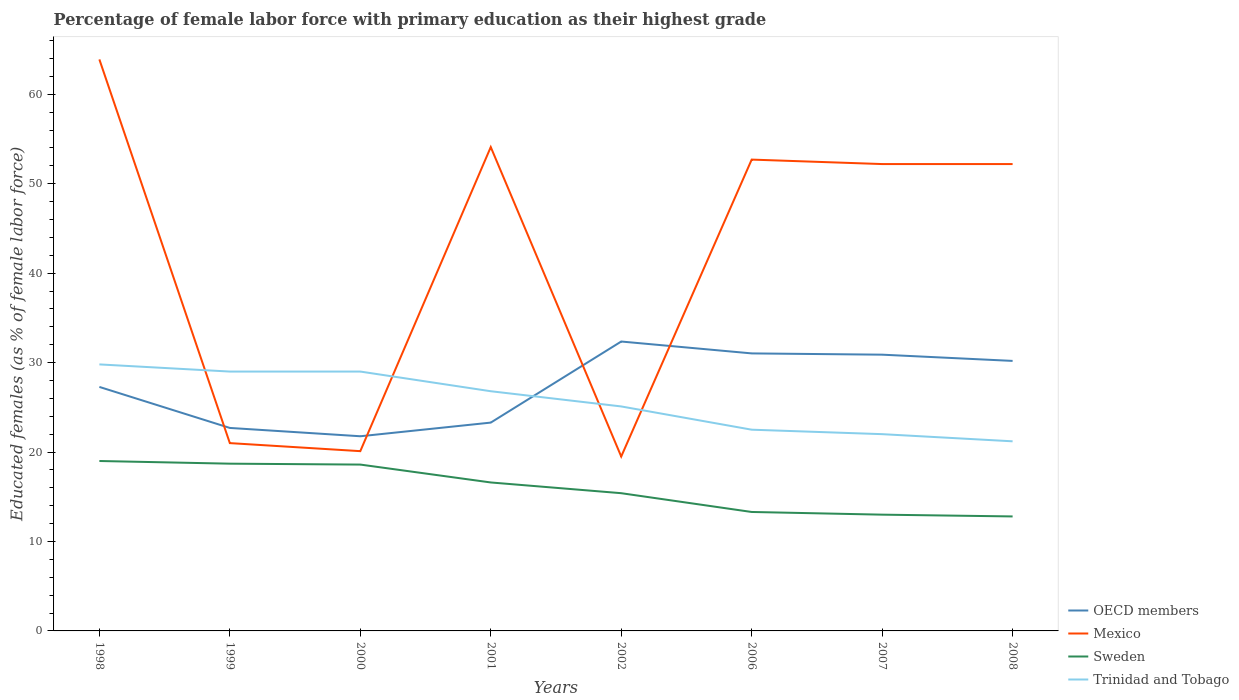How many different coloured lines are there?
Offer a terse response. 4. Does the line corresponding to Sweden intersect with the line corresponding to Trinidad and Tobago?
Keep it short and to the point. No. Across all years, what is the maximum percentage of female labor force with primary education in Sweden?
Your answer should be compact. 12.8. What is the total percentage of female labor force with primary education in Sweden in the graph?
Your answer should be compact. 2.1. What is the difference between the highest and the second highest percentage of female labor force with primary education in OECD members?
Keep it short and to the point. 10.59. What is the difference between the highest and the lowest percentage of female labor force with primary education in Trinidad and Tobago?
Provide a succinct answer. 4. Does the graph contain any zero values?
Your answer should be compact. No. Where does the legend appear in the graph?
Keep it short and to the point. Bottom right. How many legend labels are there?
Offer a terse response. 4. How are the legend labels stacked?
Your answer should be compact. Vertical. What is the title of the graph?
Make the answer very short. Percentage of female labor force with primary education as their highest grade. What is the label or title of the Y-axis?
Ensure brevity in your answer.  Educated females (as % of female labor force). What is the Educated females (as % of female labor force) of OECD members in 1998?
Give a very brief answer. 27.28. What is the Educated females (as % of female labor force) of Mexico in 1998?
Your answer should be very brief. 63.9. What is the Educated females (as % of female labor force) of Trinidad and Tobago in 1998?
Give a very brief answer. 29.8. What is the Educated females (as % of female labor force) of OECD members in 1999?
Your answer should be very brief. 22.7. What is the Educated females (as % of female labor force) in Mexico in 1999?
Give a very brief answer. 21. What is the Educated females (as % of female labor force) in Sweden in 1999?
Keep it short and to the point. 18.7. What is the Educated females (as % of female labor force) of Trinidad and Tobago in 1999?
Offer a very short reply. 29. What is the Educated females (as % of female labor force) of OECD members in 2000?
Ensure brevity in your answer.  21.77. What is the Educated females (as % of female labor force) in Mexico in 2000?
Give a very brief answer. 20.1. What is the Educated females (as % of female labor force) of Sweden in 2000?
Keep it short and to the point. 18.6. What is the Educated females (as % of female labor force) of OECD members in 2001?
Offer a very short reply. 23.29. What is the Educated females (as % of female labor force) of Mexico in 2001?
Your answer should be very brief. 54.1. What is the Educated females (as % of female labor force) of Sweden in 2001?
Offer a very short reply. 16.6. What is the Educated females (as % of female labor force) in Trinidad and Tobago in 2001?
Your response must be concise. 26.8. What is the Educated females (as % of female labor force) in OECD members in 2002?
Your answer should be very brief. 32.36. What is the Educated females (as % of female labor force) in Mexico in 2002?
Make the answer very short. 19.5. What is the Educated females (as % of female labor force) of Sweden in 2002?
Offer a terse response. 15.4. What is the Educated females (as % of female labor force) in Trinidad and Tobago in 2002?
Your response must be concise. 25.1. What is the Educated females (as % of female labor force) in OECD members in 2006?
Make the answer very short. 31.03. What is the Educated females (as % of female labor force) of Mexico in 2006?
Your answer should be compact. 52.7. What is the Educated females (as % of female labor force) of Sweden in 2006?
Provide a short and direct response. 13.3. What is the Educated females (as % of female labor force) in OECD members in 2007?
Provide a short and direct response. 30.89. What is the Educated females (as % of female labor force) of Mexico in 2007?
Ensure brevity in your answer.  52.2. What is the Educated females (as % of female labor force) in Sweden in 2007?
Your answer should be compact. 13. What is the Educated females (as % of female labor force) of Trinidad and Tobago in 2007?
Provide a short and direct response. 22. What is the Educated females (as % of female labor force) in OECD members in 2008?
Give a very brief answer. 30.19. What is the Educated females (as % of female labor force) of Mexico in 2008?
Your answer should be very brief. 52.2. What is the Educated females (as % of female labor force) of Sweden in 2008?
Give a very brief answer. 12.8. What is the Educated females (as % of female labor force) of Trinidad and Tobago in 2008?
Your answer should be compact. 21.2. Across all years, what is the maximum Educated females (as % of female labor force) of OECD members?
Offer a terse response. 32.36. Across all years, what is the maximum Educated females (as % of female labor force) in Mexico?
Ensure brevity in your answer.  63.9. Across all years, what is the maximum Educated females (as % of female labor force) of Sweden?
Your answer should be very brief. 19. Across all years, what is the maximum Educated females (as % of female labor force) of Trinidad and Tobago?
Offer a terse response. 29.8. Across all years, what is the minimum Educated females (as % of female labor force) of OECD members?
Your response must be concise. 21.77. Across all years, what is the minimum Educated females (as % of female labor force) in Mexico?
Provide a succinct answer. 19.5. Across all years, what is the minimum Educated females (as % of female labor force) in Sweden?
Your response must be concise. 12.8. Across all years, what is the minimum Educated females (as % of female labor force) in Trinidad and Tobago?
Make the answer very short. 21.2. What is the total Educated females (as % of female labor force) of OECD members in the graph?
Offer a terse response. 219.5. What is the total Educated females (as % of female labor force) in Mexico in the graph?
Your answer should be compact. 335.7. What is the total Educated females (as % of female labor force) of Sweden in the graph?
Ensure brevity in your answer.  127.4. What is the total Educated females (as % of female labor force) of Trinidad and Tobago in the graph?
Your response must be concise. 205.4. What is the difference between the Educated females (as % of female labor force) in OECD members in 1998 and that in 1999?
Provide a succinct answer. 4.59. What is the difference between the Educated females (as % of female labor force) of Mexico in 1998 and that in 1999?
Your answer should be compact. 42.9. What is the difference between the Educated females (as % of female labor force) of Sweden in 1998 and that in 1999?
Ensure brevity in your answer.  0.3. What is the difference between the Educated females (as % of female labor force) of OECD members in 1998 and that in 2000?
Give a very brief answer. 5.52. What is the difference between the Educated females (as % of female labor force) in Mexico in 1998 and that in 2000?
Provide a short and direct response. 43.8. What is the difference between the Educated females (as % of female labor force) of Sweden in 1998 and that in 2000?
Make the answer very short. 0.4. What is the difference between the Educated females (as % of female labor force) of Trinidad and Tobago in 1998 and that in 2000?
Make the answer very short. 0.8. What is the difference between the Educated females (as % of female labor force) of OECD members in 1998 and that in 2001?
Give a very brief answer. 3.99. What is the difference between the Educated females (as % of female labor force) of OECD members in 1998 and that in 2002?
Offer a terse response. -5.08. What is the difference between the Educated females (as % of female labor force) in Mexico in 1998 and that in 2002?
Offer a very short reply. 44.4. What is the difference between the Educated females (as % of female labor force) in OECD members in 1998 and that in 2006?
Your answer should be very brief. -3.75. What is the difference between the Educated females (as % of female labor force) of Mexico in 1998 and that in 2006?
Provide a short and direct response. 11.2. What is the difference between the Educated females (as % of female labor force) in Sweden in 1998 and that in 2006?
Make the answer very short. 5.7. What is the difference between the Educated females (as % of female labor force) of OECD members in 1998 and that in 2007?
Your answer should be very brief. -3.61. What is the difference between the Educated females (as % of female labor force) in Sweden in 1998 and that in 2007?
Offer a terse response. 6. What is the difference between the Educated females (as % of female labor force) of Trinidad and Tobago in 1998 and that in 2007?
Your answer should be compact. 7.8. What is the difference between the Educated females (as % of female labor force) in OECD members in 1998 and that in 2008?
Offer a very short reply. -2.91. What is the difference between the Educated females (as % of female labor force) in Sweden in 1998 and that in 2008?
Your answer should be very brief. 6.2. What is the difference between the Educated females (as % of female labor force) in Trinidad and Tobago in 1998 and that in 2008?
Offer a very short reply. 8.6. What is the difference between the Educated females (as % of female labor force) of OECD members in 1999 and that in 2000?
Keep it short and to the point. 0.93. What is the difference between the Educated females (as % of female labor force) of Sweden in 1999 and that in 2000?
Ensure brevity in your answer.  0.1. What is the difference between the Educated females (as % of female labor force) of OECD members in 1999 and that in 2001?
Give a very brief answer. -0.6. What is the difference between the Educated females (as % of female labor force) in Mexico in 1999 and that in 2001?
Offer a terse response. -33.1. What is the difference between the Educated females (as % of female labor force) in Trinidad and Tobago in 1999 and that in 2001?
Keep it short and to the point. 2.2. What is the difference between the Educated females (as % of female labor force) in OECD members in 1999 and that in 2002?
Provide a succinct answer. -9.66. What is the difference between the Educated females (as % of female labor force) in Sweden in 1999 and that in 2002?
Your answer should be compact. 3.3. What is the difference between the Educated females (as % of female labor force) of OECD members in 1999 and that in 2006?
Your answer should be very brief. -8.33. What is the difference between the Educated females (as % of female labor force) of Mexico in 1999 and that in 2006?
Ensure brevity in your answer.  -31.7. What is the difference between the Educated females (as % of female labor force) in Sweden in 1999 and that in 2006?
Give a very brief answer. 5.4. What is the difference between the Educated females (as % of female labor force) of OECD members in 1999 and that in 2007?
Keep it short and to the point. -8.19. What is the difference between the Educated females (as % of female labor force) of Mexico in 1999 and that in 2007?
Ensure brevity in your answer.  -31.2. What is the difference between the Educated females (as % of female labor force) of Sweden in 1999 and that in 2007?
Make the answer very short. 5.7. What is the difference between the Educated females (as % of female labor force) of Trinidad and Tobago in 1999 and that in 2007?
Ensure brevity in your answer.  7. What is the difference between the Educated females (as % of female labor force) of OECD members in 1999 and that in 2008?
Give a very brief answer. -7.5. What is the difference between the Educated females (as % of female labor force) of Mexico in 1999 and that in 2008?
Provide a succinct answer. -31.2. What is the difference between the Educated females (as % of female labor force) in Sweden in 1999 and that in 2008?
Offer a terse response. 5.9. What is the difference between the Educated females (as % of female labor force) in OECD members in 2000 and that in 2001?
Make the answer very short. -1.53. What is the difference between the Educated females (as % of female labor force) in Mexico in 2000 and that in 2001?
Give a very brief answer. -34. What is the difference between the Educated females (as % of female labor force) of Sweden in 2000 and that in 2001?
Make the answer very short. 2. What is the difference between the Educated females (as % of female labor force) of OECD members in 2000 and that in 2002?
Your answer should be compact. -10.59. What is the difference between the Educated females (as % of female labor force) of OECD members in 2000 and that in 2006?
Keep it short and to the point. -9.26. What is the difference between the Educated females (as % of female labor force) of Mexico in 2000 and that in 2006?
Provide a short and direct response. -32.6. What is the difference between the Educated females (as % of female labor force) in Trinidad and Tobago in 2000 and that in 2006?
Ensure brevity in your answer.  6.5. What is the difference between the Educated females (as % of female labor force) of OECD members in 2000 and that in 2007?
Offer a terse response. -9.12. What is the difference between the Educated females (as % of female labor force) in Mexico in 2000 and that in 2007?
Offer a terse response. -32.1. What is the difference between the Educated females (as % of female labor force) in Sweden in 2000 and that in 2007?
Your answer should be very brief. 5.6. What is the difference between the Educated females (as % of female labor force) of Trinidad and Tobago in 2000 and that in 2007?
Make the answer very short. 7. What is the difference between the Educated females (as % of female labor force) of OECD members in 2000 and that in 2008?
Ensure brevity in your answer.  -8.43. What is the difference between the Educated females (as % of female labor force) in Mexico in 2000 and that in 2008?
Keep it short and to the point. -32.1. What is the difference between the Educated females (as % of female labor force) in Trinidad and Tobago in 2000 and that in 2008?
Provide a succinct answer. 7.8. What is the difference between the Educated females (as % of female labor force) in OECD members in 2001 and that in 2002?
Keep it short and to the point. -9.07. What is the difference between the Educated females (as % of female labor force) of Mexico in 2001 and that in 2002?
Keep it short and to the point. 34.6. What is the difference between the Educated females (as % of female labor force) in Sweden in 2001 and that in 2002?
Your response must be concise. 1.2. What is the difference between the Educated females (as % of female labor force) in OECD members in 2001 and that in 2006?
Make the answer very short. -7.74. What is the difference between the Educated females (as % of female labor force) in Mexico in 2001 and that in 2006?
Offer a terse response. 1.4. What is the difference between the Educated females (as % of female labor force) of OECD members in 2001 and that in 2007?
Make the answer very short. -7.6. What is the difference between the Educated females (as % of female labor force) in Mexico in 2001 and that in 2007?
Offer a very short reply. 1.9. What is the difference between the Educated females (as % of female labor force) of Sweden in 2001 and that in 2007?
Your answer should be very brief. 3.6. What is the difference between the Educated females (as % of female labor force) of OECD members in 2001 and that in 2008?
Your answer should be compact. -6.9. What is the difference between the Educated females (as % of female labor force) of Mexico in 2001 and that in 2008?
Offer a terse response. 1.9. What is the difference between the Educated females (as % of female labor force) of Trinidad and Tobago in 2001 and that in 2008?
Provide a short and direct response. 5.6. What is the difference between the Educated females (as % of female labor force) in OECD members in 2002 and that in 2006?
Offer a very short reply. 1.33. What is the difference between the Educated females (as % of female labor force) of Mexico in 2002 and that in 2006?
Keep it short and to the point. -33.2. What is the difference between the Educated females (as % of female labor force) of Sweden in 2002 and that in 2006?
Ensure brevity in your answer.  2.1. What is the difference between the Educated females (as % of female labor force) of Trinidad and Tobago in 2002 and that in 2006?
Provide a short and direct response. 2.6. What is the difference between the Educated females (as % of female labor force) in OECD members in 2002 and that in 2007?
Keep it short and to the point. 1.47. What is the difference between the Educated females (as % of female labor force) in Mexico in 2002 and that in 2007?
Provide a succinct answer. -32.7. What is the difference between the Educated females (as % of female labor force) in OECD members in 2002 and that in 2008?
Offer a very short reply. 2.17. What is the difference between the Educated females (as % of female labor force) of Mexico in 2002 and that in 2008?
Your answer should be very brief. -32.7. What is the difference between the Educated females (as % of female labor force) in Sweden in 2002 and that in 2008?
Provide a succinct answer. 2.6. What is the difference between the Educated females (as % of female labor force) in OECD members in 2006 and that in 2007?
Ensure brevity in your answer.  0.14. What is the difference between the Educated females (as % of female labor force) in Sweden in 2006 and that in 2007?
Keep it short and to the point. 0.3. What is the difference between the Educated females (as % of female labor force) in OECD members in 2006 and that in 2008?
Your answer should be compact. 0.84. What is the difference between the Educated females (as % of female labor force) in OECD members in 2007 and that in 2008?
Provide a short and direct response. 0.7. What is the difference between the Educated females (as % of female labor force) of Mexico in 2007 and that in 2008?
Make the answer very short. 0. What is the difference between the Educated females (as % of female labor force) of Sweden in 2007 and that in 2008?
Your answer should be compact. 0.2. What is the difference between the Educated females (as % of female labor force) in Trinidad and Tobago in 2007 and that in 2008?
Give a very brief answer. 0.8. What is the difference between the Educated females (as % of female labor force) of OECD members in 1998 and the Educated females (as % of female labor force) of Mexico in 1999?
Offer a terse response. 6.28. What is the difference between the Educated females (as % of female labor force) in OECD members in 1998 and the Educated females (as % of female labor force) in Sweden in 1999?
Provide a short and direct response. 8.58. What is the difference between the Educated females (as % of female labor force) in OECD members in 1998 and the Educated females (as % of female labor force) in Trinidad and Tobago in 1999?
Ensure brevity in your answer.  -1.72. What is the difference between the Educated females (as % of female labor force) of Mexico in 1998 and the Educated females (as % of female labor force) of Sweden in 1999?
Give a very brief answer. 45.2. What is the difference between the Educated females (as % of female labor force) of Mexico in 1998 and the Educated females (as % of female labor force) of Trinidad and Tobago in 1999?
Your answer should be compact. 34.9. What is the difference between the Educated females (as % of female labor force) of OECD members in 1998 and the Educated females (as % of female labor force) of Mexico in 2000?
Offer a very short reply. 7.18. What is the difference between the Educated females (as % of female labor force) in OECD members in 1998 and the Educated females (as % of female labor force) in Sweden in 2000?
Offer a terse response. 8.68. What is the difference between the Educated females (as % of female labor force) of OECD members in 1998 and the Educated females (as % of female labor force) of Trinidad and Tobago in 2000?
Ensure brevity in your answer.  -1.72. What is the difference between the Educated females (as % of female labor force) of Mexico in 1998 and the Educated females (as % of female labor force) of Sweden in 2000?
Your answer should be compact. 45.3. What is the difference between the Educated females (as % of female labor force) in Mexico in 1998 and the Educated females (as % of female labor force) in Trinidad and Tobago in 2000?
Provide a succinct answer. 34.9. What is the difference between the Educated females (as % of female labor force) in OECD members in 1998 and the Educated females (as % of female labor force) in Mexico in 2001?
Give a very brief answer. -26.82. What is the difference between the Educated females (as % of female labor force) in OECD members in 1998 and the Educated females (as % of female labor force) in Sweden in 2001?
Make the answer very short. 10.68. What is the difference between the Educated females (as % of female labor force) of OECD members in 1998 and the Educated females (as % of female labor force) of Trinidad and Tobago in 2001?
Your answer should be compact. 0.48. What is the difference between the Educated females (as % of female labor force) of Mexico in 1998 and the Educated females (as % of female labor force) of Sweden in 2001?
Provide a succinct answer. 47.3. What is the difference between the Educated females (as % of female labor force) of Mexico in 1998 and the Educated females (as % of female labor force) of Trinidad and Tobago in 2001?
Your response must be concise. 37.1. What is the difference between the Educated females (as % of female labor force) of OECD members in 1998 and the Educated females (as % of female labor force) of Mexico in 2002?
Offer a very short reply. 7.78. What is the difference between the Educated females (as % of female labor force) of OECD members in 1998 and the Educated females (as % of female labor force) of Sweden in 2002?
Make the answer very short. 11.88. What is the difference between the Educated females (as % of female labor force) in OECD members in 1998 and the Educated females (as % of female labor force) in Trinidad and Tobago in 2002?
Your answer should be compact. 2.18. What is the difference between the Educated females (as % of female labor force) of Mexico in 1998 and the Educated females (as % of female labor force) of Sweden in 2002?
Offer a very short reply. 48.5. What is the difference between the Educated females (as % of female labor force) in Mexico in 1998 and the Educated females (as % of female labor force) in Trinidad and Tobago in 2002?
Your response must be concise. 38.8. What is the difference between the Educated females (as % of female labor force) of OECD members in 1998 and the Educated females (as % of female labor force) of Mexico in 2006?
Offer a very short reply. -25.42. What is the difference between the Educated females (as % of female labor force) of OECD members in 1998 and the Educated females (as % of female labor force) of Sweden in 2006?
Your answer should be very brief. 13.98. What is the difference between the Educated females (as % of female labor force) of OECD members in 1998 and the Educated females (as % of female labor force) of Trinidad and Tobago in 2006?
Your answer should be very brief. 4.78. What is the difference between the Educated females (as % of female labor force) of Mexico in 1998 and the Educated females (as % of female labor force) of Sweden in 2006?
Offer a terse response. 50.6. What is the difference between the Educated females (as % of female labor force) in Mexico in 1998 and the Educated females (as % of female labor force) in Trinidad and Tobago in 2006?
Provide a short and direct response. 41.4. What is the difference between the Educated females (as % of female labor force) in Sweden in 1998 and the Educated females (as % of female labor force) in Trinidad and Tobago in 2006?
Provide a succinct answer. -3.5. What is the difference between the Educated females (as % of female labor force) in OECD members in 1998 and the Educated females (as % of female labor force) in Mexico in 2007?
Provide a short and direct response. -24.92. What is the difference between the Educated females (as % of female labor force) of OECD members in 1998 and the Educated females (as % of female labor force) of Sweden in 2007?
Your answer should be compact. 14.28. What is the difference between the Educated females (as % of female labor force) of OECD members in 1998 and the Educated females (as % of female labor force) of Trinidad and Tobago in 2007?
Your answer should be very brief. 5.28. What is the difference between the Educated females (as % of female labor force) of Mexico in 1998 and the Educated females (as % of female labor force) of Sweden in 2007?
Your answer should be compact. 50.9. What is the difference between the Educated females (as % of female labor force) in Mexico in 1998 and the Educated females (as % of female labor force) in Trinidad and Tobago in 2007?
Ensure brevity in your answer.  41.9. What is the difference between the Educated females (as % of female labor force) of Sweden in 1998 and the Educated females (as % of female labor force) of Trinidad and Tobago in 2007?
Provide a succinct answer. -3. What is the difference between the Educated females (as % of female labor force) of OECD members in 1998 and the Educated females (as % of female labor force) of Mexico in 2008?
Your answer should be very brief. -24.92. What is the difference between the Educated females (as % of female labor force) of OECD members in 1998 and the Educated females (as % of female labor force) of Sweden in 2008?
Give a very brief answer. 14.48. What is the difference between the Educated females (as % of female labor force) of OECD members in 1998 and the Educated females (as % of female labor force) of Trinidad and Tobago in 2008?
Your response must be concise. 6.08. What is the difference between the Educated females (as % of female labor force) of Mexico in 1998 and the Educated females (as % of female labor force) of Sweden in 2008?
Offer a very short reply. 51.1. What is the difference between the Educated females (as % of female labor force) of Mexico in 1998 and the Educated females (as % of female labor force) of Trinidad and Tobago in 2008?
Make the answer very short. 42.7. What is the difference between the Educated females (as % of female labor force) of Sweden in 1998 and the Educated females (as % of female labor force) of Trinidad and Tobago in 2008?
Give a very brief answer. -2.2. What is the difference between the Educated females (as % of female labor force) of OECD members in 1999 and the Educated females (as % of female labor force) of Mexico in 2000?
Offer a very short reply. 2.6. What is the difference between the Educated females (as % of female labor force) of OECD members in 1999 and the Educated females (as % of female labor force) of Sweden in 2000?
Offer a terse response. 4.1. What is the difference between the Educated females (as % of female labor force) of OECD members in 1999 and the Educated females (as % of female labor force) of Trinidad and Tobago in 2000?
Make the answer very short. -6.3. What is the difference between the Educated females (as % of female labor force) in Mexico in 1999 and the Educated females (as % of female labor force) in Trinidad and Tobago in 2000?
Your response must be concise. -8. What is the difference between the Educated females (as % of female labor force) of Sweden in 1999 and the Educated females (as % of female labor force) of Trinidad and Tobago in 2000?
Provide a succinct answer. -10.3. What is the difference between the Educated females (as % of female labor force) of OECD members in 1999 and the Educated females (as % of female labor force) of Mexico in 2001?
Your answer should be very brief. -31.4. What is the difference between the Educated females (as % of female labor force) of OECD members in 1999 and the Educated females (as % of female labor force) of Sweden in 2001?
Offer a very short reply. 6.1. What is the difference between the Educated females (as % of female labor force) of OECD members in 1999 and the Educated females (as % of female labor force) of Trinidad and Tobago in 2001?
Your answer should be compact. -4.1. What is the difference between the Educated females (as % of female labor force) in Mexico in 1999 and the Educated females (as % of female labor force) in Sweden in 2001?
Your response must be concise. 4.4. What is the difference between the Educated females (as % of female labor force) in OECD members in 1999 and the Educated females (as % of female labor force) in Mexico in 2002?
Provide a short and direct response. 3.2. What is the difference between the Educated females (as % of female labor force) in OECD members in 1999 and the Educated females (as % of female labor force) in Sweden in 2002?
Make the answer very short. 7.3. What is the difference between the Educated females (as % of female labor force) of OECD members in 1999 and the Educated females (as % of female labor force) of Trinidad and Tobago in 2002?
Give a very brief answer. -2.4. What is the difference between the Educated females (as % of female labor force) of Sweden in 1999 and the Educated females (as % of female labor force) of Trinidad and Tobago in 2002?
Keep it short and to the point. -6.4. What is the difference between the Educated females (as % of female labor force) of OECD members in 1999 and the Educated females (as % of female labor force) of Mexico in 2006?
Offer a terse response. -30. What is the difference between the Educated females (as % of female labor force) of OECD members in 1999 and the Educated females (as % of female labor force) of Sweden in 2006?
Provide a succinct answer. 9.4. What is the difference between the Educated females (as % of female labor force) of OECD members in 1999 and the Educated females (as % of female labor force) of Trinidad and Tobago in 2006?
Make the answer very short. 0.2. What is the difference between the Educated females (as % of female labor force) of Mexico in 1999 and the Educated females (as % of female labor force) of Sweden in 2006?
Keep it short and to the point. 7.7. What is the difference between the Educated females (as % of female labor force) in Mexico in 1999 and the Educated females (as % of female labor force) in Trinidad and Tobago in 2006?
Your response must be concise. -1.5. What is the difference between the Educated females (as % of female labor force) in OECD members in 1999 and the Educated females (as % of female labor force) in Mexico in 2007?
Provide a succinct answer. -29.5. What is the difference between the Educated females (as % of female labor force) of OECD members in 1999 and the Educated females (as % of female labor force) of Sweden in 2007?
Ensure brevity in your answer.  9.7. What is the difference between the Educated females (as % of female labor force) in OECD members in 1999 and the Educated females (as % of female labor force) in Trinidad and Tobago in 2007?
Provide a succinct answer. 0.7. What is the difference between the Educated females (as % of female labor force) in Mexico in 1999 and the Educated females (as % of female labor force) in Sweden in 2007?
Offer a very short reply. 8. What is the difference between the Educated females (as % of female labor force) of Mexico in 1999 and the Educated females (as % of female labor force) of Trinidad and Tobago in 2007?
Offer a very short reply. -1. What is the difference between the Educated females (as % of female labor force) in Sweden in 1999 and the Educated females (as % of female labor force) in Trinidad and Tobago in 2007?
Provide a short and direct response. -3.3. What is the difference between the Educated females (as % of female labor force) of OECD members in 1999 and the Educated females (as % of female labor force) of Mexico in 2008?
Your answer should be compact. -29.5. What is the difference between the Educated females (as % of female labor force) of OECD members in 1999 and the Educated females (as % of female labor force) of Sweden in 2008?
Make the answer very short. 9.9. What is the difference between the Educated females (as % of female labor force) in OECD members in 1999 and the Educated females (as % of female labor force) in Trinidad and Tobago in 2008?
Your answer should be compact. 1.5. What is the difference between the Educated females (as % of female labor force) of OECD members in 2000 and the Educated females (as % of female labor force) of Mexico in 2001?
Your answer should be compact. -32.33. What is the difference between the Educated females (as % of female labor force) in OECD members in 2000 and the Educated females (as % of female labor force) in Sweden in 2001?
Give a very brief answer. 5.17. What is the difference between the Educated females (as % of female labor force) of OECD members in 2000 and the Educated females (as % of female labor force) of Trinidad and Tobago in 2001?
Ensure brevity in your answer.  -5.03. What is the difference between the Educated females (as % of female labor force) in OECD members in 2000 and the Educated females (as % of female labor force) in Mexico in 2002?
Make the answer very short. 2.27. What is the difference between the Educated females (as % of female labor force) of OECD members in 2000 and the Educated females (as % of female labor force) of Sweden in 2002?
Provide a succinct answer. 6.37. What is the difference between the Educated females (as % of female labor force) of OECD members in 2000 and the Educated females (as % of female labor force) of Trinidad and Tobago in 2002?
Make the answer very short. -3.33. What is the difference between the Educated females (as % of female labor force) of Mexico in 2000 and the Educated females (as % of female labor force) of Sweden in 2002?
Give a very brief answer. 4.7. What is the difference between the Educated females (as % of female labor force) in Sweden in 2000 and the Educated females (as % of female labor force) in Trinidad and Tobago in 2002?
Offer a terse response. -6.5. What is the difference between the Educated females (as % of female labor force) in OECD members in 2000 and the Educated females (as % of female labor force) in Mexico in 2006?
Provide a succinct answer. -30.93. What is the difference between the Educated females (as % of female labor force) of OECD members in 2000 and the Educated females (as % of female labor force) of Sweden in 2006?
Provide a short and direct response. 8.47. What is the difference between the Educated females (as % of female labor force) in OECD members in 2000 and the Educated females (as % of female labor force) in Trinidad and Tobago in 2006?
Your answer should be compact. -0.73. What is the difference between the Educated females (as % of female labor force) in Mexico in 2000 and the Educated females (as % of female labor force) in Trinidad and Tobago in 2006?
Your answer should be very brief. -2.4. What is the difference between the Educated females (as % of female labor force) of OECD members in 2000 and the Educated females (as % of female labor force) of Mexico in 2007?
Offer a very short reply. -30.43. What is the difference between the Educated females (as % of female labor force) of OECD members in 2000 and the Educated females (as % of female labor force) of Sweden in 2007?
Provide a succinct answer. 8.77. What is the difference between the Educated females (as % of female labor force) of OECD members in 2000 and the Educated females (as % of female labor force) of Trinidad and Tobago in 2007?
Provide a succinct answer. -0.23. What is the difference between the Educated females (as % of female labor force) of OECD members in 2000 and the Educated females (as % of female labor force) of Mexico in 2008?
Keep it short and to the point. -30.43. What is the difference between the Educated females (as % of female labor force) in OECD members in 2000 and the Educated females (as % of female labor force) in Sweden in 2008?
Provide a short and direct response. 8.97. What is the difference between the Educated females (as % of female labor force) in OECD members in 2000 and the Educated females (as % of female labor force) in Trinidad and Tobago in 2008?
Ensure brevity in your answer.  0.57. What is the difference between the Educated females (as % of female labor force) in Mexico in 2000 and the Educated females (as % of female labor force) in Sweden in 2008?
Your response must be concise. 7.3. What is the difference between the Educated females (as % of female labor force) of Sweden in 2000 and the Educated females (as % of female labor force) of Trinidad and Tobago in 2008?
Keep it short and to the point. -2.6. What is the difference between the Educated females (as % of female labor force) in OECD members in 2001 and the Educated females (as % of female labor force) in Mexico in 2002?
Keep it short and to the point. 3.79. What is the difference between the Educated females (as % of female labor force) in OECD members in 2001 and the Educated females (as % of female labor force) in Sweden in 2002?
Ensure brevity in your answer.  7.89. What is the difference between the Educated females (as % of female labor force) in OECD members in 2001 and the Educated females (as % of female labor force) in Trinidad and Tobago in 2002?
Keep it short and to the point. -1.81. What is the difference between the Educated females (as % of female labor force) in Mexico in 2001 and the Educated females (as % of female labor force) in Sweden in 2002?
Keep it short and to the point. 38.7. What is the difference between the Educated females (as % of female labor force) in OECD members in 2001 and the Educated females (as % of female labor force) in Mexico in 2006?
Ensure brevity in your answer.  -29.41. What is the difference between the Educated females (as % of female labor force) in OECD members in 2001 and the Educated females (as % of female labor force) in Sweden in 2006?
Keep it short and to the point. 9.99. What is the difference between the Educated females (as % of female labor force) in OECD members in 2001 and the Educated females (as % of female labor force) in Trinidad and Tobago in 2006?
Give a very brief answer. 0.79. What is the difference between the Educated females (as % of female labor force) in Mexico in 2001 and the Educated females (as % of female labor force) in Sweden in 2006?
Offer a terse response. 40.8. What is the difference between the Educated females (as % of female labor force) in Mexico in 2001 and the Educated females (as % of female labor force) in Trinidad and Tobago in 2006?
Keep it short and to the point. 31.6. What is the difference between the Educated females (as % of female labor force) in Sweden in 2001 and the Educated females (as % of female labor force) in Trinidad and Tobago in 2006?
Provide a succinct answer. -5.9. What is the difference between the Educated females (as % of female labor force) in OECD members in 2001 and the Educated females (as % of female labor force) in Mexico in 2007?
Your answer should be very brief. -28.91. What is the difference between the Educated females (as % of female labor force) in OECD members in 2001 and the Educated females (as % of female labor force) in Sweden in 2007?
Ensure brevity in your answer.  10.29. What is the difference between the Educated females (as % of female labor force) of OECD members in 2001 and the Educated females (as % of female labor force) of Trinidad and Tobago in 2007?
Your answer should be very brief. 1.29. What is the difference between the Educated females (as % of female labor force) of Mexico in 2001 and the Educated females (as % of female labor force) of Sweden in 2007?
Ensure brevity in your answer.  41.1. What is the difference between the Educated females (as % of female labor force) in Mexico in 2001 and the Educated females (as % of female labor force) in Trinidad and Tobago in 2007?
Offer a terse response. 32.1. What is the difference between the Educated females (as % of female labor force) in OECD members in 2001 and the Educated females (as % of female labor force) in Mexico in 2008?
Make the answer very short. -28.91. What is the difference between the Educated females (as % of female labor force) of OECD members in 2001 and the Educated females (as % of female labor force) of Sweden in 2008?
Ensure brevity in your answer.  10.49. What is the difference between the Educated females (as % of female labor force) in OECD members in 2001 and the Educated females (as % of female labor force) in Trinidad and Tobago in 2008?
Keep it short and to the point. 2.09. What is the difference between the Educated females (as % of female labor force) in Mexico in 2001 and the Educated females (as % of female labor force) in Sweden in 2008?
Your answer should be compact. 41.3. What is the difference between the Educated females (as % of female labor force) in Mexico in 2001 and the Educated females (as % of female labor force) in Trinidad and Tobago in 2008?
Provide a short and direct response. 32.9. What is the difference between the Educated females (as % of female labor force) of Sweden in 2001 and the Educated females (as % of female labor force) of Trinidad and Tobago in 2008?
Your response must be concise. -4.6. What is the difference between the Educated females (as % of female labor force) in OECD members in 2002 and the Educated females (as % of female labor force) in Mexico in 2006?
Make the answer very short. -20.34. What is the difference between the Educated females (as % of female labor force) of OECD members in 2002 and the Educated females (as % of female labor force) of Sweden in 2006?
Your response must be concise. 19.06. What is the difference between the Educated females (as % of female labor force) in OECD members in 2002 and the Educated females (as % of female labor force) in Trinidad and Tobago in 2006?
Provide a succinct answer. 9.86. What is the difference between the Educated females (as % of female labor force) of Mexico in 2002 and the Educated females (as % of female labor force) of Trinidad and Tobago in 2006?
Provide a short and direct response. -3. What is the difference between the Educated females (as % of female labor force) of OECD members in 2002 and the Educated females (as % of female labor force) of Mexico in 2007?
Give a very brief answer. -19.84. What is the difference between the Educated females (as % of female labor force) in OECD members in 2002 and the Educated females (as % of female labor force) in Sweden in 2007?
Your response must be concise. 19.36. What is the difference between the Educated females (as % of female labor force) of OECD members in 2002 and the Educated females (as % of female labor force) of Trinidad and Tobago in 2007?
Provide a short and direct response. 10.36. What is the difference between the Educated females (as % of female labor force) in Mexico in 2002 and the Educated females (as % of female labor force) in Trinidad and Tobago in 2007?
Ensure brevity in your answer.  -2.5. What is the difference between the Educated females (as % of female labor force) of Sweden in 2002 and the Educated females (as % of female labor force) of Trinidad and Tobago in 2007?
Your answer should be very brief. -6.6. What is the difference between the Educated females (as % of female labor force) of OECD members in 2002 and the Educated females (as % of female labor force) of Mexico in 2008?
Your answer should be compact. -19.84. What is the difference between the Educated females (as % of female labor force) of OECD members in 2002 and the Educated females (as % of female labor force) of Sweden in 2008?
Ensure brevity in your answer.  19.56. What is the difference between the Educated females (as % of female labor force) of OECD members in 2002 and the Educated females (as % of female labor force) of Trinidad and Tobago in 2008?
Offer a very short reply. 11.16. What is the difference between the Educated females (as % of female labor force) of Mexico in 2002 and the Educated females (as % of female labor force) of Sweden in 2008?
Give a very brief answer. 6.7. What is the difference between the Educated females (as % of female labor force) in OECD members in 2006 and the Educated females (as % of female labor force) in Mexico in 2007?
Ensure brevity in your answer.  -21.17. What is the difference between the Educated females (as % of female labor force) in OECD members in 2006 and the Educated females (as % of female labor force) in Sweden in 2007?
Ensure brevity in your answer.  18.03. What is the difference between the Educated females (as % of female labor force) in OECD members in 2006 and the Educated females (as % of female labor force) in Trinidad and Tobago in 2007?
Provide a succinct answer. 9.03. What is the difference between the Educated females (as % of female labor force) in Mexico in 2006 and the Educated females (as % of female labor force) in Sweden in 2007?
Your answer should be compact. 39.7. What is the difference between the Educated females (as % of female labor force) of Mexico in 2006 and the Educated females (as % of female labor force) of Trinidad and Tobago in 2007?
Offer a terse response. 30.7. What is the difference between the Educated females (as % of female labor force) of OECD members in 2006 and the Educated females (as % of female labor force) of Mexico in 2008?
Keep it short and to the point. -21.17. What is the difference between the Educated females (as % of female labor force) in OECD members in 2006 and the Educated females (as % of female labor force) in Sweden in 2008?
Your answer should be compact. 18.23. What is the difference between the Educated females (as % of female labor force) in OECD members in 2006 and the Educated females (as % of female labor force) in Trinidad and Tobago in 2008?
Make the answer very short. 9.83. What is the difference between the Educated females (as % of female labor force) of Mexico in 2006 and the Educated females (as % of female labor force) of Sweden in 2008?
Ensure brevity in your answer.  39.9. What is the difference between the Educated females (as % of female labor force) in Mexico in 2006 and the Educated females (as % of female labor force) in Trinidad and Tobago in 2008?
Make the answer very short. 31.5. What is the difference between the Educated females (as % of female labor force) of OECD members in 2007 and the Educated females (as % of female labor force) of Mexico in 2008?
Provide a short and direct response. -21.31. What is the difference between the Educated females (as % of female labor force) in OECD members in 2007 and the Educated females (as % of female labor force) in Sweden in 2008?
Keep it short and to the point. 18.09. What is the difference between the Educated females (as % of female labor force) of OECD members in 2007 and the Educated females (as % of female labor force) of Trinidad and Tobago in 2008?
Your answer should be compact. 9.69. What is the difference between the Educated females (as % of female labor force) in Mexico in 2007 and the Educated females (as % of female labor force) in Sweden in 2008?
Your answer should be very brief. 39.4. What is the difference between the Educated females (as % of female labor force) in Sweden in 2007 and the Educated females (as % of female labor force) in Trinidad and Tobago in 2008?
Offer a very short reply. -8.2. What is the average Educated females (as % of female labor force) of OECD members per year?
Give a very brief answer. 27.44. What is the average Educated females (as % of female labor force) of Mexico per year?
Your response must be concise. 41.96. What is the average Educated females (as % of female labor force) of Sweden per year?
Your answer should be very brief. 15.93. What is the average Educated females (as % of female labor force) in Trinidad and Tobago per year?
Your answer should be very brief. 25.68. In the year 1998, what is the difference between the Educated females (as % of female labor force) of OECD members and Educated females (as % of female labor force) of Mexico?
Ensure brevity in your answer.  -36.62. In the year 1998, what is the difference between the Educated females (as % of female labor force) in OECD members and Educated females (as % of female labor force) in Sweden?
Give a very brief answer. 8.28. In the year 1998, what is the difference between the Educated females (as % of female labor force) in OECD members and Educated females (as % of female labor force) in Trinidad and Tobago?
Give a very brief answer. -2.52. In the year 1998, what is the difference between the Educated females (as % of female labor force) of Mexico and Educated females (as % of female labor force) of Sweden?
Keep it short and to the point. 44.9. In the year 1998, what is the difference between the Educated females (as % of female labor force) of Mexico and Educated females (as % of female labor force) of Trinidad and Tobago?
Make the answer very short. 34.1. In the year 1998, what is the difference between the Educated females (as % of female labor force) in Sweden and Educated females (as % of female labor force) in Trinidad and Tobago?
Make the answer very short. -10.8. In the year 1999, what is the difference between the Educated females (as % of female labor force) of OECD members and Educated females (as % of female labor force) of Mexico?
Provide a short and direct response. 1.7. In the year 1999, what is the difference between the Educated females (as % of female labor force) in OECD members and Educated females (as % of female labor force) in Sweden?
Provide a succinct answer. 4. In the year 1999, what is the difference between the Educated females (as % of female labor force) in OECD members and Educated females (as % of female labor force) in Trinidad and Tobago?
Keep it short and to the point. -6.3. In the year 2000, what is the difference between the Educated females (as % of female labor force) of OECD members and Educated females (as % of female labor force) of Mexico?
Your response must be concise. 1.67. In the year 2000, what is the difference between the Educated females (as % of female labor force) of OECD members and Educated females (as % of female labor force) of Sweden?
Provide a succinct answer. 3.17. In the year 2000, what is the difference between the Educated females (as % of female labor force) in OECD members and Educated females (as % of female labor force) in Trinidad and Tobago?
Give a very brief answer. -7.23. In the year 2000, what is the difference between the Educated females (as % of female labor force) of Mexico and Educated females (as % of female labor force) of Sweden?
Offer a very short reply. 1.5. In the year 2000, what is the difference between the Educated females (as % of female labor force) in Mexico and Educated females (as % of female labor force) in Trinidad and Tobago?
Your answer should be very brief. -8.9. In the year 2001, what is the difference between the Educated females (as % of female labor force) in OECD members and Educated females (as % of female labor force) in Mexico?
Keep it short and to the point. -30.81. In the year 2001, what is the difference between the Educated females (as % of female labor force) in OECD members and Educated females (as % of female labor force) in Sweden?
Give a very brief answer. 6.69. In the year 2001, what is the difference between the Educated females (as % of female labor force) of OECD members and Educated females (as % of female labor force) of Trinidad and Tobago?
Keep it short and to the point. -3.51. In the year 2001, what is the difference between the Educated females (as % of female labor force) of Mexico and Educated females (as % of female labor force) of Sweden?
Your answer should be very brief. 37.5. In the year 2001, what is the difference between the Educated females (as % of female labor force) of Mexico and Educated females (as % of female labor force) of Trinidad and Tobago?
Your answer should be very brief. 27.3. In the year 2002, what is the difference between the Educated females (as % of female labor force) in OECD members and Educated females (as % of female labor force) in Mexico?
Your response must be concise. 12.86. In the year 2002, what is the difference between the Educated females (as % of female labor force) of OECD members and Educated females (as % of female labor force) of Sweden?
Offer a terse response. 16.96. In the year 2002, what is the difference between the Educated females (as % of female labor force) in OECD members and Educated females (as % of female labor force) in Trinidad and Tobago?
Offer a terse response. 7.26. In the year 2002, what is the difference between the Educated females (as % of female labor force) of Sweden and Educated females (as % of female labor force) of Trinidad and Tobago?
Offer a terse response. -9.7. In the year 2006, what is the difference between the Educated females (as % of female labor force) of OECD members and Educated females (as % of female labor force) of Mexico?
Give a very brief answer. -21.67. In the year 2006, what is the difference between the Educated females (as % of female labor force) in OECD members and Educated females (as % of female labor force) in Sweden?
Keep it short and to the point. 17.73. In the year 2006, what is the difference between the Educated females (as % of female labor force) of OECD members and Educated females (as % of female labor force) of Trinidad and Tobago?
Your answer should be very brief. 8.53. In the year 2006, what is the difference between the Educated females (as % of female labor force) in Mexico and Educated females (as % of female labor force) in Sweden?
Provide a short and direct response. 39.4. In the year 2006, what is the difference between the Educated females (as % of female labor force) in Mexico and Educated females (as % of female labor force) in Trinidad and Tobago?
Your answer should be very brief. 30.2. In the year 2006, what is the difference between the Educated females (as % of female labor force) in Sweden and Educated females (as % of female labor force) in Trinidad and Tobago?
Offer a terse response. -9.2. In the year 2007, what is the difference between the Educated females (as % of female labor force) of OECD members and Educated females (as % of female labor force) of Mexico?
Give a very brief answer. -21.31. In the year 2007, what is the difference between the Educated females (as % of female labor force) in OECD members and Educated females (as % of female labor force) in Sweden?
Your response must be concise. 17.89. In the year 2007, what is the difference between the Educated females (as % of female labor force) in OECD members and Educated females (as % of female labor force) in Trinidad and Tobago?
Your answer should be very brief. 8.89. In the year 2007, what is the difference between the Educated females (as % of female labor force) in Mexico and Educated females (as % of female labor force) in Sweden?
Ensure brevity in your answer.  39.2. In the year 2007, what is the difference between the Educated females (as % of female labor force) in Mexico and Educated females (as % of female labor force) in Trinidad and Tobago?
Give a very brief answer. 30.2. In the year 2008, what is the difference between the Educated females (as % of female labor force) of OECD members and Educated females (as % of female labor force) of Mexico?
Provide a succinct answer. -22.01. In the year 2008, what is the difference between the Educated females (as % of female labor force) of OECD members and Educated females (as % of female labor force) of Sweden?
Make the answer very short. 17.39. In the year 2008, what is the difference between the Educated females (as % of female labor force) of OECD members and Educated females (as % of female labor force) of Trinidad and Tobago?
Give a very brief answer. 8.99. In the year 2008, what is the difference between the Educated females (as % of female labor force) in Mexico and Educated females (as % of female labor force) in Sweden?
Your answer should be compact. 39.4. What is the ratio of the Educated females (as % of female labor force) of OECD members in 1998 to that in 1999?
Your answer should be compact. 1.2. What is the ratio of the Educated females (as % of female labor force) of Mexico in 1998 to that in 1999?
Provide a succinct answer. 3.04. What is the ratio of the Educated females (as % of female labor force) in Sweden in 1998 to that in 1999?
Provide a short and direct response. 1.02. What is the ratio of the Educated females (as % of female labor force) in Trinidad and Tobago in 1998 to that in 1999?
Give a very brief answer. 1.03. What is the ratio of the Educated females (as % of female labor force) of OECD members in 1998 to that in 2000?
Give a very brief answer. 1.25. What is the ratio of the Educated females (as % of female labor force) of Mexico in 1998 to that in 2000?
Give a very brief answer. 3.18. What is the ratio of the Educated females (as % of female labor force) of Sweden in 1998 to that in 2000?
Your answer should be very brief. 1.02. What is the ratio of the Educated females (as % of female labor force) of Trinidad and Tobago in 1998 to that in 2000?
Your answer should be very brief. 1.03. What is the ratio of the Educated females (as % of female labor force) in OECD members in 1998 to that in 2001?
Offer a very short reply. 1.17. What is the ratio of the Educated females (as % of female labor force) in Mexico in 1998 to that in 2001?
Make the answer very short. 1.18. What is the ratio of the Educated females (as % of female labor force) in Sweden in 1998 to that in 2001?
Your answer should be compact. 1.14. What is the ratio of the Educated females (as % of female labor force) in Trinidad and Tobago in 1998 to that in 2001?
Provide a short and direct response. 1.11. What is the ratio of the Educated females (as % of female labor force) in OECD members in 1998 to that in 2002?
Your answer should be very brief. 0.84. What is the ratio of the Educated females (as % of female labor force) of Mexico in 1998 to that in 2002?
Give a very brief answer. 3.28. What is the ratio of the Educated females (as % of female labor force) of Sweden in 1998 to that in 2002?
Provide a short and direct response. 1.23. What is the ratio of the Educated females (as % of female labor force) in Trinidad and Tobago in 1998 to that in 2002?
Keep it short and to the point. 1.19. What is the ratio of the Educated females (as % of female labor force) of OECD members in 1998 to that in 2006?
Your response must be concise. 0.88. What is the ratio of the Educated females (as % of female labor force) of Mexico in 1998 to that in 2006?
Offer a terse response. 1.21. What is the ratio of the Educated females (as % of female labor force) of Sweden in 1998 to that in 2006?
Make the answer very short. 1.43. What is the ratio of the Educated females (as % of female labor force) of Trinidad and Tobago in 1998 to that in 2006?
Your answer should be very brief. 1.32. What is the ratio of the Educated females (as % of female labor force) in OECD members in 1998 to that in 2007?
Your response must be concise. 0.88. What is the ratio of the Educated females (as % of female labor force) of Mexico in 1998 to that in 2007?
Offer a terse response. 1.22. What is the ratio of the Educated females (as % of female labor force) of Sweden in 1998 to that in 2007?
Ensure brevity in your answer.  1.46. What is the ratio of the Educated females (as % of female labor force) in Trinidad and Tobago in 1998 to that in 2007?
Your answer should be compact. 1.35. What is the ratio of the Educated females (as % of female labor force) in OECD members in 1998 to that in 2008?
Your answer should be very brief. 0.9. What is the ratio of the Educated females (as % of female labor force) of Mexico in 1998 to that in 2008?
Your answer should be very brief. 1.22. What is the ratio of the Educated females (as % of female labor force) in Sweden in 1998 to that in 2008?
Offer a very short reply. 1.48. What is the ratio of the Educated females (as % of female labor force) of Trinidad and Tobago in 1998 to that in 2008?
Provide a succinct answer. 1.41. What is the ratio of the Educated females (as % of female labor force) in OECD members in 1999 to that in 2000?
Your response must be concise. 1.04. What is the ratio of the Educated females (as % of female labor force) in Mexico in 1999 to that in 2000?
Your answer should be very brief. 1.04. What is the ratio of the Educated females (as % of female labor force) in Sweden in 1999 to that in 2000?
Make the answer very short. 1.01. What is the ratio of the Educated females (as % of female labor force) of Trinidad and Tobago in 1999 to that in 2000?
Provide a short and direct response. 1. What is the ratio of the Educated females (as % of female labor force) in OECD members in 1999 to that in 2001?
Provide a succinct answer. 0.97. What is the ratio of the Educated females (as % of female labor force) in Mexico in 1999 to that in 2001?
Ensure brevity in your answer.  0.39. What is the ratio of the Educated females (as % of female labor force) of Sweden in 1999 to that in 2001?
Give a very brief answer. 1.13. What is the ratio of the Educated females (as % of female labor force) of Trinidad and Tobago in 1999 to that in 2001?
Your response must be concise. 1.08. What is the ratio of the Educated females (as % of female labor force) of OECD members in 1999 to that in 2002?
Offer a terse response. 0.7. What is the ratio of the Educated females (as % of female labor force) in Sweden in 1999 to that in 2002?
Keep it short and to the point. 1.21. What is the ratio of the Educated females (as % of female labor force) of Trinidad and Tobago in 1999 to that in 2002?
Your response must be concise. 1.16. What is the ratio of the Educated females (as % of female labor force) of OECD members in 1999 to that in 2006?
Your answer should be very brief. 0.73. What is the ratio of the Educated females (as % of female labor force) in Mexico in 1999 to that in 2006?
Offer a very short reply. 0.4. What is the ratio of the Educated females (as % of female labor force) in Sweden in 1999 to that in 2006?
Keep it short and to the point. 1.41. What is the ratio of the Educated females (as % of female labor force) of Trinidad and Tobago in 1999 to that in 2006?
Your answer should be very brief. 1.29. What is the ratio of the Educated females (as % of female labor force) of OECD members in 1999 to that in 2007?
Offer a terse response. 0.73. What is the ratio of the Educated females (as % of female labor force) of Mexico in 1999 to that in 2007?
Offer a very short reply. 0.4. What is the ratio of the Educated females (as % of female labor force) in Sweden in 1999 to that in 2007?
Give a very brief answer. 1.44. What is the ratio of the Educated females (as % of female labor force) in Trinidad and Tobago in 1999 to that in 2007?
Give a very brief answer. 1.32. What is the ratio of the Educated females (as % of female labor force) of OECD members in 1999 to that in 2008?
Make the answer very short. 0.75. What is the ratio of the Educated females (as % of female labor force) in Mexico in 1999 to that in 2008?
Your answer should be compact. 0.4. What is the ratio of the Educated females (as % of female labor force) in Sweden in 1999 to that in 2008?
Your answer should be very brief. 1.46. What is the ratio of the Educated females (as % of female labor force) in Trinidad and Tobago in 1999 to that in 2008?
Offer a very short reply. 1.37. What is the ratio of the Educated females (as % of female labor force) in OECD members in 2000 to that in 2001?
Give a very brief answer. 0.93. What is the ratio of the Educated females (as % of female labor force) of Mexico in 2000 to that in 2001?
Offer a very short reply. 0.37. What is the ratio of the Educated females (as % of female labor force) in Sweden in 2000 to that in 2001?
Ensure brevity in your answer.  1.12. What is the ratio of the Educated females (as % of female labor force) in Trinidad and Tobago in 2000 to that in 2001?
Offer a terse response. 1.08. What is the ratio of the Educated females (as % of female labor force) in OECD members in 2000 to that in 2002?
Your answer should be very brief. 0.67. What is the ratio of the Educated females (as % of female labor force) of Mexico in 2000 to that in 2002?
Your answer should be very brief. 1.03. What is the ratio of the Educated females (as % of female labor force) in Sweden in 2000 to that in 2002?
Your answer should be compact. 1.21. What is the ratio of the Educated females (as % of female labor force) of Trinidad and Tobago in 2000 to that in 2002?
Your answer should be compact. 1.16. What is the ratio of the Educated females (as % of female labor force) of OECD members in 2000 to that in 2006?
Provide a short and direct response. 0.7. What is the ratio of the Educated females (as % of female labor force) in Mexico in 2000 to that in 2006?
Your answer should be compact. 0.38. What is the ratio of the Educated females (as % of female labor force) in Sweden in 2000 to that in 2006?
Provide a short and direct response. 1.4. What is the ratio of the Educated females (as % of female labor force) of Trinidad and Tobago in 2000 to that in 2006?
Your response must be concise. 1.29. What is the ratio of the Educated females (as % of female labor force) in OECD members in 2000 to that in 2007?
Provide a short and direct response. 0.7. What is the ratio of the Educated females (as % of female labor force) of Mexico in 2000 to that in 2007?
Your response must be concise. 0.39. What is the ratio of the Educated females (as % of female labor force) in Sweden in 2000 to that in 2007?
Offer a very short reply. 1.43. What is the ratio of the Educated females (as % of female labor force) of Trinidad and Tobago in 2000 to that in 2007?
Ensure brevity in your answer.  1.32. What is the ratio of the Educated females (as % of female labor force) of OECD members in 2000 to that in 2008?
Give a very brief answer. 0.72. What is the ratio of the Educated females (as % of female labor force) in Mexico in 2000 to that in 2008?
Your response must be concise. 0.39. What is the ratio of the Educated females (as % of female labor force) in Sweden in 2000 to that in 2008?
Make the answer very short. 1.45. What is the ratio of the Educated females (as % of female labor force) of Trinidad and Tobago in 2000 to that in 2008?
Give a very brief answer. 1.37. What is the ratio of the Educated females (as % of female labor force) of OECD members in 2001 to that in 2002?
Give a very brief answer. 0.72. What is the ratio of the Educated females (as % of female labor force) in Mexico in 2001 to that in 2002?
Your answer should be compact. 2.77. What is the ratio of the Educated females (as % of female labor force) of Sweden in 2001 to that in 2002?
Ensure brevity in your answer.  1.08. What is the ratio of the Educated females (as % of female labor force) of Trinidad and Tobago in 2001 to that in 2002?
Your answer should be compact. 1.07. What is the ratio of the Educated females (as % of female labor force) in OECD members in 2001 to that in 2006?
Ensure brevity in your answer.  0.75. What is the ratio of the Educated females (as % of female labor force) in Mexico in 2001 to that in 2006?
Provide a succinct answer. 1.03. What is the ratio of the Educated females (as % of female labor force) of Sweden in 2001 to that in 2006?
Ensure brevity in your answer.  1.25. What is the ratio of the Educated females (as % of female labor force) in Trinidad and Tobago in 2001 to that in 2006?
Your response must be concise. 1.19. What is the ratio of the Educated females (as % of female labor force) in OECD members in 2001 to that in 2007?
Offer a terse response. 0.75. What is the ratio of the Educated females (as % of female labor force) in Mexico in 2001 to that in 2007?
Your answer should be compact. 1.04. What is the ratio of the Educated females (as % of female labor force) in Sweden in 2001 to that in 2007?
Give a very brief answer. 1.28. What is the ratio of the Educated females (as % of female labor force) in Trinidad and Tobago in 2001 to that in 2007?
Your answer should be compact. 1.22. What is the ratio of the Educated females (as % of female labor force) of OECD members in 2001 to that in 2008?
Ensure brevity in your answer.  0.77. What is the ratio of the Educated females (as % of female labor force) of Mexico in 2001 to that in 2008?
Your answer should be compact. 1.04. What is the ratio of the Educated females (as % of female labor force) in Sweden in 2001 to that in 2008?
Provide a succinct answer. 1.3. What is the ratio of the Educated females (as % of female labor force) of Trinidad and Tobago in 2001 to that in 2008?
Offer a very short reply. 1.26. What is the ratio of the Educated females (as % of female labor force) in OECD members in 2002 to that in 2006?
Your answer should be compact. 1.04. What is the ratio of the Educated females (as % of female labor force) of Mexico in 2002 to that in 2006?
Offer a terse response. 0.37. What is the ratio of the Educated females (as % of female labor force) of Sweden in 2002 to that in 2006?
Provide a short and direct response. 1.16. What is the ratio of the Educated females (as % of female labor force) of Trinidad and Tobago in 2002 to that in 2006?
Make the answer very short. 1.12. What is the ratio of the Educated females (as % of female labor force) in OECD members in 2002 to that in 2007?
Your answer should be very brief. 1.05. What is the ratio of the Educated females (as % of female labor force) of Mexico in 2002 to that in 2007?
Your response must be concise. 0.37. What is the ratio of the Educated females (as % of female labor force) of Sweden in 2002 to that in 2007?
Your answer should be very brief. 1.18. What is the ratio of the Educated females (as % of female labor force) in Trinidad and Tobago in 2002 to that in 2007?
Give a very brief answer. 1.14. What is the ratio of the Educated females (as % of female labor force) in OECD members in 2002 to that in 2008?
Provide a succinct answer. 1.07. What is the ratio of the Educated females (as % of female labor force) in Mexico in 2002 to that in 2008?
Offer a terse response. 0.37. What is the ratio of the Educated females (as % of female labor force) in Sweden in 2002 to that in 2008?
Keep it short and to the point. 1.2. What is the ratio of the Educated females (as % of female labor force) of Trinidad and Tobago in 2002 to that in 2008?
Give a very brief answer. 1.18. What is the ratio of the Educated females (as % of female labor force) in OECD members in 2006 to that in 2007?
Keep it short and to the point. 1. What is the ratio of the Educated females (as % of female labor force) in Mexico in 2006 to that in 2007?
Your response must be concise. 1.01. What is the ratio of the Educated females (as % of female labor force) of Sweden in 2006 to that in 2007?
Your response must be concise. 1.02. What is the ratio of the Educated females (as % of female labor force) of Trinidad and Tobago in 2006 to that in 2007?
Offer a terse response. 1.02. What is the ratio of the Educated females (as % of female labor force) of OECD members in 2006 to that in 2008?
Offer a terse response. 1.03. What is the ratio of the Educated females (as % of female labor force) in Mexico in 2006 to that in 2008?
Give a very brief answer. 1.01. What is the ratio of the Educated females (as % of female labor force) in Sweden in 2006 to that in 2008?
Your response must be concise. 1.04. What is the ratio of the Educated females (as % of female labor force) in Trinidad and Tobago in 2006 to that in 2008?
Make the answer very short. 1.06. What is the ratio of the Educated females (as % of female labor force) of OECD members in 2007 to that in 2008?
Keep it short and to the point. 1.02. What is the ratio of the Educated females (as % of female labor force) of Mexico in 2007 to that in 2008?
Offer a very short reply. 1. What is the ratio of the Educated females (as % of female labor force) in Sweden in 2007 to that in 2008?
Keep it short and to the point. 1.02. What is the ratio of the Educated females (as % of female labor force) in Trinidad and Tobago in 2007 to that in 2008?
Offer a very short reply. 1.04. What is the difference between the highest and the second highest Educated females (as % of female labor force) of OECD members?
Offer a very short reply. 1.33. What is the difference between the highest and the second highest Educated females (as % of female labor force) of Sweden?
Give a very brief answer. 0.3. What is the difference between the highest and the lowest Educated females (as % of female labor force) in OECD members?
Keep it short and to the point. 10.59. What is the difference between the highest and the lowest Educated females (as % of female labor force) in Mexico?
Offer a terse response. 44.4. What is the difference between the highest and the lowest Educated females (as % of female labor force) in Trinidad and Tobago?
Offer a very short reply. 8.6. 